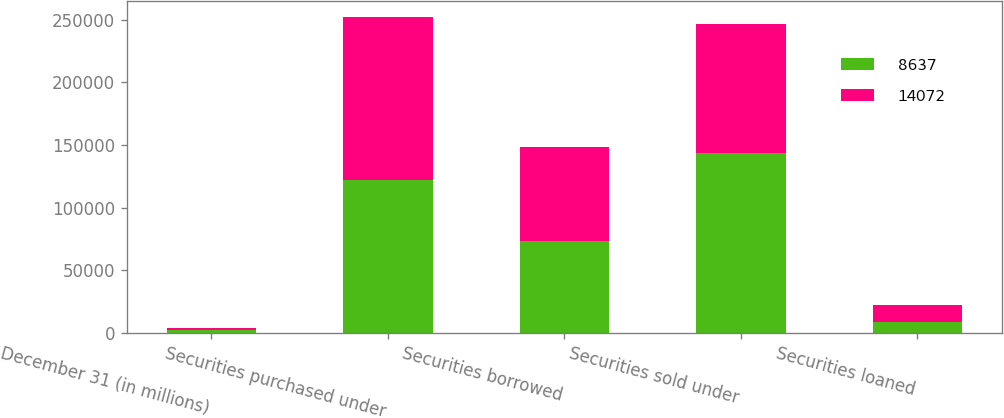<chart> <loc_0><loc_0><loc_500><loc_500><stacked_bar_chart><ecel><fcel>December 31 (in millions)<fcel>Securities purchased under<fcel>Securities borrowed<fcel>Securities sold under<fcel>Securities loaned<nl><fcel>8637<fcel>2006<fcel>122479<fcel>73688<fcel>143253<fcel>8637<nl><fcel>14072<fcel>2005<fcel>129570<fcel>74604<fcel>103052<fcel>14072<nl></chart> 